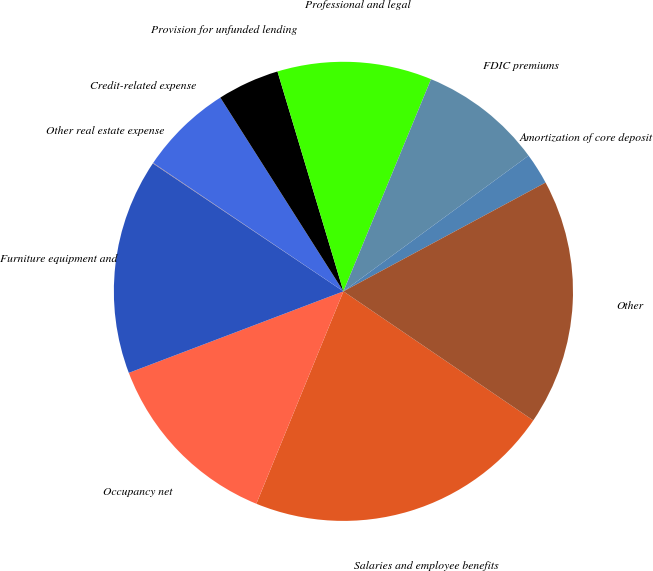<chart> <loc_0><loc_0><loc_500><loc_500><pie_chart><fcel>Salaries and employee benefits<fcel>Occupancy net<fcel>Furniture equipment and<fcel>Other real estate expense<fcel>Credit-related expense<fcel>Provision for unfunded lending<fcel>Professional and legal<fcel>FDIC premiums<fcel>Amortization of core deposit<fcel>Other<nl><fcel>21.69%<fcel>13.03%<fcel>15.19%<fcel>0.04%<fcel>6.54%<fcel>4.37%<fcel>10.87%<fcel>8.7%<fcel>2.21%<fcel>17.36%<nl></chart> 